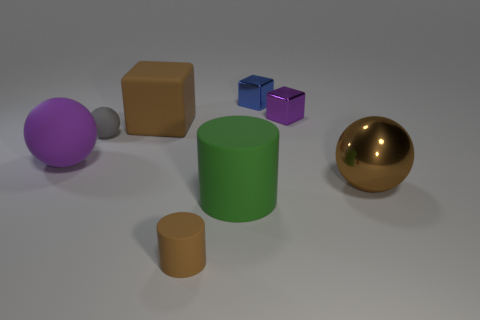Subtract 1 balls. How many balls are left? 2 Add 2 brown shiny objects. How many objects exist? 10 Subtract all blocks. How many objects are left? 5 Subtract 0 yellow cylinders. How many objects are left? 8 Subtract all tiny matte balls. Subtract all tiny matte spheres. How many objects are left? 6 Add 5 gray matte balls. How many gray matte balls are left? 6 Add 4 blue metallic spheres. How many blue metallic spheres exist? 4 